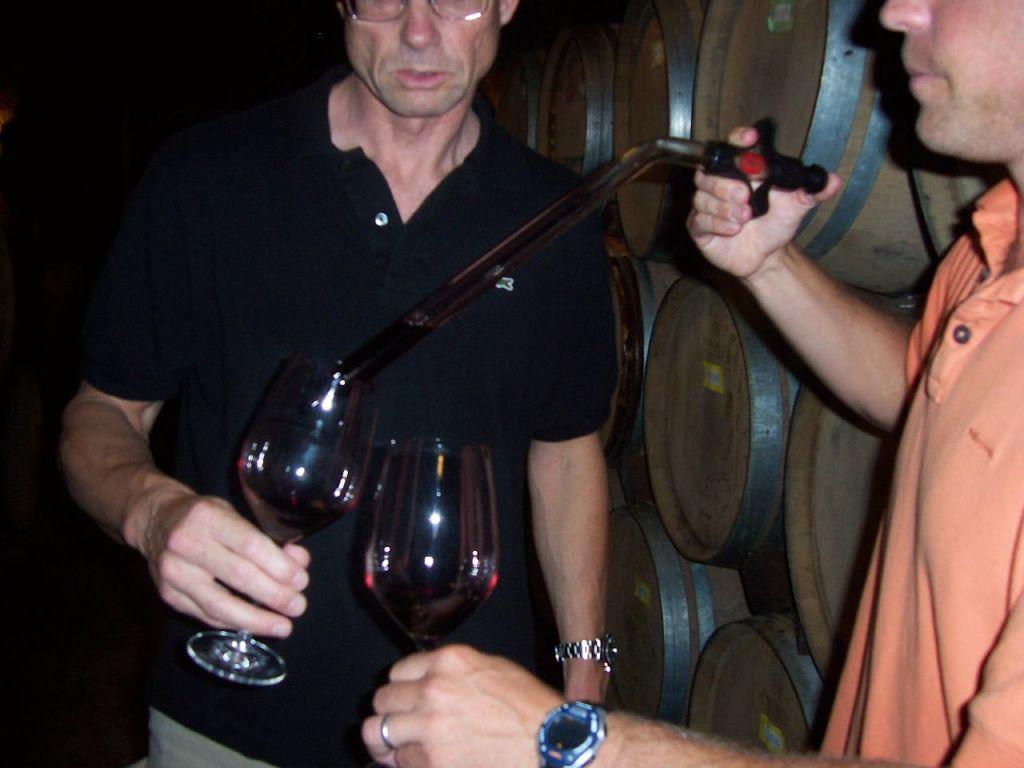What is the main subject of the image? There is a man standing in the middle of the image. What is the man in the middle holding? The man in the middle is holding a glass. Are there any other people in the image? Yes, there is another man standing in the bottom right side of the image. What is the man in the bottom right side holding? The man in the bottom right side is holding a glass. What type of seed is the man in the bottom right side planting in the image? There is no seed or planting activity depicted in the image; it features two men holding glasses. What type of root can be seen growing from the man in the middle's foot in the image? There is no root or any indication of plant growth in the image; it only shows two men holding glasses. 